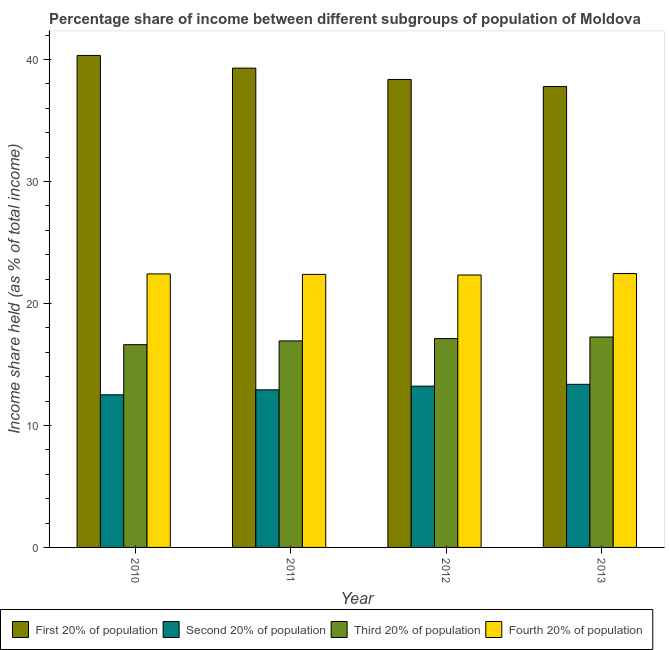Are the number of bars per tick equal to the number of legend labels?
Your answer should be compact. Yes. Are the number of bars on each tick of the X-axis equal?
Make the answer very short. Yes. What is the label of the 3rd group of bars from the left?
Keep it short and to the point. 2012. What is the share of the income held by second 20% of the population in 2013?
Ensure brevity in your answer.  13.37. Across all years, what is the maximum share of the income held by third 20% of the population?
Make the answer very short. 17.25. Across all years, what is the minimum share of the income held by first 20% of the population?
Give a very brief answer. 37.78. In which year was the share of the income held by first 20% of the population maximum?
Ensure brevity in your answer.  2010. In which year was the share of the income held by third 20% of the population minimum?
Your response must be concise. 2010. What is the total share of the income held by second 20% of the population in the graph?
Your answer should be compact. 52.02. What is the difference between the share of the income held by fourth 20% of the population in 2010 and that in 2013?
Provide a short and direct response. -0.03. What is the difference between the share of the income held by second 20% of the population in 2010 and the share of the income held by third 20% of the population in 2012?
Your answer should be very brief. -0.71. What is the average share of the income held by second 20% of the population per year?
Keep it short and to the point. 13. In the year 2012, what is the difference between the share of the income held by third 20% of the population and share of the income held by second 20% of the population?
Provide a succinct answer. 0. What is the ratio of the share of the income held by fourth 20% of the population in 2010 to that in 2011?
Your response must be concise. 1. Is the share of the income held by first 20% of the population in 2011 less than that in 2013?
Ensure brevity in your answer.  No. Is the difference between the share of the income held by second 20% of the population in 2010 and 2011 greater than the difference between the share of the income held by first 20% of the population in 2010 and 2011?
Your response must be concise. No. What is the difference between the highest and the second highest share of the income held by third 20% of the population?
Keep it short and to the point. 0.13. What is the difference between the highest and the lowest share of the income held by fourth 20% of the population?
Keep it short and to the point. 0.12. Is the sum of the share of the income held by second 20% of the population in 2010 and 2011 greater than the maximum share of the income held by first 20% of the population across all years?
Provide a succinct answer. Yes. Is it the case that in every year, the sum of the share of the income held by fourth 20% of the population and share of the income held by third 20% of the population is greater than the sum of share of the income held by second 20% of the population and share of the income held by first 20% of the population?
Ensure brevity in your answer.  Yes. What does the 3rd bar from the left in 2013 represents?
Offer a terse response. Third 20% of population. What does the 2nd bar from the right in 2013 represents?
Offer a very short reply. Third 20% of population. Is it the case that in every year, the sum of the share of the income held by first 20% of the population and share of the income held by second 20% of the population is greater than the share of the income held by third 20% of the population?
Offer a terse response. Yes. Are all the bars in the graph horizontal?
Your answer should be compact. No. How many years are there in the graph?
Give a very brief answer. 4. What is the difference between two consecutive major ticks on the Y-axis?
Your answer should be compact. 10. Are the values on the major ticks of Y-axis written in scientific E-notation?
Offer a very short reply. No. Does the graph contain any zero values?
Offer a terse response. No. Does the graph contain grids?
Your response must be concise. No. Where does the legend appear in the graph?
Your answer should be compact. Bottom left. How many legend labels are there?
Make the answer very short. 4. How are the legend labels stacked?
Make the answer very short. Horizontal. What is the title of the graph?
Your answer should be compact. Percentage share of income between different subgroups of population of Moldova. What is the label or title of the X-axis?
Offer a terse response. Year. What is the label or title of the Y-axis?
Make the answer very short. Income share held (as % of total income). What is the Income share held (as % of total income) of First 20% of population in 2010?
Keep it short and to the point. 40.33. What is the Income share held (as % of total income) of Second 20% of population in 2010?
Ensure brevity in your answer.  12.51. What is the Income share held (as % of total income) in Third 20% of population in 2010?
Give a very brief answer. 16.62. What is the Income share held (as % of total income) of Fourth 20% of population in 2010?
Make the answer very short. 22.42. What is the Income share held (as % of total income) in First 20% of population in 2011?
Offer a terse response. 39.29. What is the Income share held (as % of total income) of Second 20% of population in 2011?
Keep it short and to the point. 12.92. What is the Income share held (as % of total income) in Third 20% of population in 2011?
Offer a terse response. 16.93. What is the Income share held (as % of total income) of Fourth 20% of population in 2011?
Give a very brief answer. 22.38. What is the Income share held (as % of total income) of First 20% of population in 2012?
Your answer should be compact. 38.36. What is the Income share held (as % of total income) in Second 20% of population in 2012?
Offer a very short reply. 13.22. What is the Income share held (as % of total income) of Third 20% of population in 2012?
Your answer should be very brief. 17.12. What is the Income share held (as % of total income) in Fourth 20% of population in 2012?
Offer a very short reply. 22.33. What is the Income share held (as % of total income) of First 20% of population in 2013?
Give a very brief answer. 37.78. What is the Income share held (as % of total income) in Second 20% of population in 2013?
Make the answer very short. 13.37. What is the Income share held (as % of total income) of Third 20% of population in 2013?
Make the answer very short. 17.25. What is the Income share held (as % of total income) in Fourth 20% of population in 2013?
Keep it short and to the point. 22.45. Across all years, what is the maximum Income share held (as % of total income) in First 20% of population?
Offer a very short reply. 40.33. Across all years, what is the maximum Income share held (as % of total income) of Second 20% of population?
Give a very brief answer. 13.37. Across all years, what is the maximum Income share held (as % of total income) of Third 20% of population?
Offer a very short reply. 17.25. Across all years, what is the maximum Income share held (as % of total income) of Fourth 20% of population?
Your answer should be compact. 22.45. Across all years, what is the minimum Income share held (as % of total income) in First 20% of population?
Ensure brevity in your answer.  37.78. Across all years, what is the minimum Income share held (as % of total income) of Second 20% of population?
Your answer should be compact. 12.51. Across all years, what is the minimum Income share held (as % of total income) in Third 20% of population?
Provide a succinct answer. 16.62. Across all years, what is the minimum Income share held (as % of total income) of Fourth 20% of population?
Offer a terse response. 22.33. What is the total Income share held (as % of total income) in First 20% of population in the graph?
Make the answer very short. 155.76. What is the total Income share held (as % of total income) in Second 20% of population in the graph?
Provide a short and direct response. 52.02. What is the total Income share held (as % of total income) in Third 20% of population in the graph?
Your response must be concise. 67.92. What is the total Income share held (as % of total income) in Fourth 20% of population in the graph?
Provide a succinct answer. 89.58. What is the difference between the Income share held (as % of total income) in First 20% of population in 2010 and that in 2011?
Your response must be concise. 1.04. What is the difference between the Income share held (as % of total income) of Second 20% of population in 2010 and that in 2011?
Keep it short and to the point. -0.41. What is the difference between the Income share held (as % of total income) of Third 20% of population in 2010 and that in 2011?
Offer a terse response. -0.31. What is the difference between the Income share held (as % of total income) of Fourth 20% of population in 2010 and that in 2011?
Ensure brevity in your answer.  0.04. What is the difference between the Income share held (as % of total income) of First 20% of population in 2010 and that in 2012?
Make the answer very short. 1.97. What is the difference between the Income share held (as % of total income) in Second 20% of population in 2010 and that in 2012?
Give a very brief answer. -0.71. What is the difference between the Income share held (as % of total income) in Fourth 20% of population in 2010 and that in 2012?
Provide a short and direct response. 0.09. What is the difference between the Income share held (as % of total income) of First 20% of population in 2010 and that in 2013?
Your response must be concise. 2.55. What is the difference between the Income share held (as % of total income) of Second 20% of population in 2010 and that in 2013?
Ensure brevity in your answer.  -0.86. What is the difference between the Income share held (as % of total income) of Third 20% of population in 2010 and that in 2013?
Offer a terse response. -0.63. What is the difference between the Income share held (as % of total income) in Fourth 20% of population in 2010 and that in 2013?
Your response must be concise. -0.03. What is the difference between the Income share held (as % of total income) of Second 20% of population in 2011 and that in 2012?
Your answer should be very brief. -0.3. What is the difference between the Income share held (as % of total income) of Third 20% of population in 2011 and that in 2012?
Provide a succinct answer. -0.19. What is the difference between the Income share held (as % of total income) of First 20% of population in 2011 and that in 2013?
Your answer should be compact. 1.51. What is the difference between the Income share held (as % of total income) in Second 20% of population in 2011 and that in 2013?
Your response must be concise. -0.45. What is the difference between the Income share held (as % of total income) in Third 20% of population in 2011 and that in 2013?
Provide a succinct answer. -0.32. What is the difference between the Income share held (as % of total income) in Fourth 20% of population in 2011 and that in 2013?
Your answer should be compact. -0.07. What is the difference between the Income share held (as % of total income) of First 20% of population in 2012 and that in 2013?
Your response must be concise. 0.58. What is the difference between the Income share held (as % of total income) of Second 20% of population in 2012 and that in 2013?
Provide a short and direct response. -0.15. What is the difference between the Income share held (as % of total income) of Third 20% of population in 2012 and that in 2013?
Make the answer very short. -0.13. What is the difference between the Income share held (as % of total income) of Fourth 20% of population in 2012 and that in 2013?
Provide a short and direct response. -0.12. What is the difference between the Income share held (as % of total income) in First 20% of population in 2010 and the Income share held (as % of total income) in Second 20% of population in 2011?
Your answer should be very brief. 27.41. What is the difference between the Income share held (as % of total income) of First 20% of population in 2010 and the Income share held (as % of total income) of Third 20% of population in 2011?
Provide a succinct answer. 23.4. What is the difference between the Income share held (as % of total income) of First 20% of population in 2010 and the Income share held (as % of total income) of Fourth 20% of population in 2011?
Your answer should be very brief. 17.95. What is the difference between the Income share held (as % of total income) in Second 20% of population in 2010 and the Income share held (as % of total income) in Third 20% of population in 2011?
Provide a succinct answer. -4.42. What is the difference between the Income share held (as % of total income) in Second 20% of population in 2010 and the Income share held (as % of total income) in Fourth 20% of population in 2011?
Keep it short and to the point. -9.87. What is the difference between the Income share held (as % of total income) in Third 20% of population in 2010 and the Income share held (as % of total income) in Fourth 20% of population in 2011?
Provide a succinct answer. -5.76. What is the difference between the Income share held (as % of total income) in First 20% of population in 2010 and the Income share held (as % of total income) in Second 20% of population in 2012?
Your answer should be compact. 27.11. What is the difference between the Income share held (as % of total income) in First 20% of population in 2010 and the Income share held (as % of total income) in Third 20% of population in 2012?
Your response must be concise. 23.21. What is the difference between the Income share held (as % of total income) of Second 20% of population in 2010 and the Income share held (as % of total income) of Third 20% of population in 2012?
Your answer should be compact. -4.61. What is the difference between the Income share held (as % of total income) of Second 20% of population in 2010 and the Income share held (as % of total income) of Fourth 20% of population in 2012?
Your answer should be compact. -9.82. What is the difference between the Income share held (as % of total income) in Third 20% of population in 2010 and the Income share held (as % of total income) in Fourth 20% of population in 2012?
Provide a succinct answer. -5.71. What is the difference between the Income share held (as % of total income) in First 20% of population in 2010 and the Income share held (as % of total income) in Second 20% of population in 2013?
Your response must be concise. 26.96. What is the difference between the Income share held (as % of total income) in First 20% of population in 2010 and the Income share held (as % of total income) in Third 20% of population in 2013?
Keep it short and to the point. 23.08. What is the difference between the Income share held (as % of total income) in First 20% of population in 2010 and the Income share held (as % of total income) in Fourth 20% of population in 2013?
Offer a terse response. 17.88. What is the difference between the Income share held (as % of total income) of Second 20% of population in 2010 and the Income share held (as % of total income) of Third 20% of population in 2013?
Provide a short and direct response. -4.74. What is the difference between the Income share held (as % of total income) in Second 20% of population in 2010 and the Income share held (as % of total income) in Fourth 20% of population in 2013?
Offer a terse response. -9.94. What is the difference between the Income share held (as % of total income) of Third 20% of population in 2010 and the Income share held (as % of total income) of Fourth 20% of population in 2013?
Ensure brevity in your answer.  -5.83. What is the difference between the Income share held (as % of total income) of First 20% of population in 2011 and the Income share held (as % of total income) of Second 20% of population in 2012?
Ensure brevity in your answer.  26.07. What is the difference between the Income share held (as % of total income) in First 20% of population in 2011 and the Income share held (as % of total income) in Third 20% of population in 2012?
Offer a terse response. 22.17. What is the difference between the Income share held (as % of total income) of First 20% of population in 2011 and the Income share held (as % of total income) of Fourth 20% of population in 2012?
Offer a terse response. 16.96. What is the difference between the Income share held (as % of total income) of Second 20% of population in 2011 and the Income share held (as % of total income) of Fourth 20% of population in 2012?
Offer a very short reply. -9.41. What is the difference between the Income share held (as % of total income) of First 20% of population in 2011 and the Income share held (as % of total income) of Second 20% of population in 2013?
Provide a short and direct response. 25.92. What is the difference between the Income share held (as % of total income) of First 20% of population in 2011 and the Income share held (as % of total income) of Third 20% of population in 2013?
Give a very brief answer. 22.04. What is the difference between the Income share held (as % of total income) of First 20% of population in 2011 and the Income share held (as % of total income) of Fourth 20% of population in 2013?
Your response must be concise. 16.84. What is the difference between the Income share held (as % of total income) of Second 20% of population in 2011 and the Income share held (as % of total income) of Third 20% of population in 2013?
Provide a short and direct response. -4.33. What is the difference between the Income share held (as % of total income) in Second 20% of population in 2011 and the Income share held (as % of total income) in Fourth 20% of population in 2013?
Give a very brief answer. -9.53. What is the difference between the Income share held (as % of total income) of Third 20% of population in 2011 and the Income share held (as % of total income) of Fourth 20% of population in 2013?
Your answer should be compact. -5.52. What is the difference between the Income share held (as % of total income) in First 20% of population in 2012 and the Income share held (as % of total income) in Second 20% of population in 2013?
Provide a short and direct response. 24.99. What is the difference between the Income share held (as % of total income) of First 20% of population in 2012 and the Income share held (as % of total income) of Third 20% of population in 2013?
Your answer should be compact. 21.11. What is the difference between the Income share held (as % of total income) in First 20% of population in 2012 and the Income share held (as % of total income) in Fourth 20% of population in 2013?
Provide a short and direct response. 15.91. What is the difference between the Income share held (as % of total income) in Second 20% of population in 2012 and the Income share held (as % of total income) in Third 20% of population in 2013?
Ensure brevity in your answer.  -4.03. What is the difference between the Income share held (as % of total income) in Second 20% of population in 2012 and the Income share held (as % of total income) in Fourth 20% of population in 2013?
Provide a succinct answer. -9.23. What is the difference between the Income share held (as % of total income) of Third 20% of population in 2012 and the Income share held (as % of total income) of Fourth 20% of population in 2013?
Make the answer very short. -5.33. What is the average Income share held (as % of total income) in First 20% of population per year?
Offer a terse response. 38.94. What is the average Income share held (as % of total income) of Second 20% of population per year?
Offer a very short reply. 13.01. What is the average Income share held (as % of total income) in Third 20% of population per year?
Your answer should be very brief. 16.98. What is the average Income share held (as % of total income) of Fourth 20% of population per year?
Offer a terse response. 22.39. In the year 2010, what is the difference between the Income share held (as % of total income) of First 20% of population and Income share held (as % of total income) of Second 20% of population?
Make the answer very short. 27.82. In the year 2010, what is the difference between the Income share held (as % of total income) in First 20% of population and Income share held (as % of total income) in Third 20% of population?
Your answer should be very brief. 23.71. In the year 2010, what is the difference between the Income share held (as % of total income) in First 20% of population and Income share held (as % of total income) in Fourth 20% of population?
Provide a short and direct response. 17.91. In the year 2010, what is the difference between the Income share held (as % of total income) of Second 20% of population and Income share held (as % of total income) of Third 20% of population?
Your response must be concise. -4.11. In the year 2010, what is the difference between the Income share held (as % of total income) in Second 20% of population and Income share held (as % of total income) in Fourth 20% of population?
Offer a terse response. -9.91. In the year 2010, what is the difference between the Income share held (as % of total income) of Third 20% of population and Income share held (as % of total income) of Fourth 20% of population?
Your answer should be compact. -5.8. In the year 2011, what is the difference between the Income share held (as % of total income) of First 20% of population and Income share held (as % of total income) of Second 20% of population?
Ensure brevity in your answer.  26.37. In the year 2011, what is the difference between the Income share held (as % of total income) in First 20% of population and Income share held (as % of total income) in Third 20% of population?
Provide a short and direct response. 22.36. In the year 2011, what is the difference between the Income share held (as % of total income) of First 20% of population and Income share held (as % of total income) of Fourth 20% of population?
Make the answer very short. 16.91. In the year 2011, what is the difference between the Income share held (as % of total income) in Second 20% of population and Income share held (as % of total income) in Third 20% of population?
Provide a succinct answer. -4.01. In the year 2011, what is the difference between the Income share held (as % of total income) of Second 20% of population and Income share held (as % of total income) of Fourth 20% of population?
Provide a short and direct response. -9.46. In the year 2011, what is the difference between the Income share held (as % of total income) of Third 20% of population and Income share held (as % of total income) of Fourth 20% of population?
Your response must be concise. -5.45. In the year 2012, what is the difference between the Income share held (as % of total income) in First 20% of population and Income share held (as % of total income) in Second 20% of population?
Your answer should be compact. 25.14. In the year 2012, what is the difference between the Income share held (as % of total income) of First 20% of population and Income share held (as % of total income) of Third 20% of population?
Keep it short and to the point. 21.24. In the year 2012, what is the difference between the Income share held (as % of total income) of First 20% of population and Income share held (as % of total income) of Fourth 20% of population?
Ensure brevity in your answer.  16.03. In the year 2012, what is the difference between the Income share held (as % of total income) in Second 20% of population and Income share held (as % of total income) in Third 20% of population?
Give a very brief answer. -3.9. In the year 2012, what is the difference between the Income share held (as % of total income) of Second 20% of population and Income share held (as % of total income) of Fourth 20% of population?
Provide a succinct answer. -9.11. In the year 2012, what is the difference between the Income share held (as % of total income) in Third 20% of population and Income share held (as % of total income) in Fourth 20% of population?
Provide a succinct answer. -5.21. In the year 2013, what is the difference between the Income share held (as % of total income) in First 20% of population and Income share held (as % of total income) in Second 20% of population?
Keep it short and to the point. 24.41. In the year 2013, what is the difference between the Income share held (as % of total income) in First 20% of population and Income share held (as % of total income) in Third 20% of population?
Give a very brief answer. 20.53. In the year 2013, what is the difference between the Income share held (as % of total income) of First 20% of population and Income share held (as % of total income) of Fourth 20% of population?
Keep it short and to the point. 15.33. In the year 2013, what is the difference between the Income share held (as % of total income) in Second 20% of population and Income share held (as % of total income) in Third 20% of population?
Give a very brief answer. -3.88. In the year 2013, what is the difference between the Income share held (as % of total income) of Second 20% of population and Income share held (as % of total income) of Fourth 20% of population?
Offer a very short reply. -9.08. What is the ratio of the Income share held (as % of total income) of First 20% of population in 2010 to that in 2011?
Make the answer very short. 1.03. What is the ratio of the Income share held (as % of total income) of Second 20% of population in 2010 to that in 2011?
Your answer should be very brief. 0.97. What is the ratio of the Income share held (as % of total income) in Third 20% of population in 2010 to that in 2011?
Provide a short and direct response. 0.98. What is the ratio of the Income share held (as % of total income) of First 20% of population in 2010 to that in 2012?
Your answer should be compact. 1.05. What is the ratio of the Income share held (as % of total income) in Second 20% of population in 2010 to that in 2012?
Your answer should be compact. 0.95. What is the ratio of the Income share held (as % of total income) in Third 20% of population in 2010 to that in 2012?
Your answer should be very brief. 0.97. What is the ratio of the Income share held (as % of total income) in First 20% of population in 2010 to that in 2013?
Ensure brevity in your answer.  1.07. What is the ratio of the Income share held (as % of total income) in Second 20% of population in 2010 to that in 2013?
Offer a very short reply. 0.94. What is the ratio of the Income share held (as % of total income) of Third 20% of population in 2010 to that in 2013?
Give a very brief answer. 0.96. What is the ratio of the Income share held (as % of total income) of First 20% of population in 2011 to that in 2012?
Offer a terse response. 1.02. What is the ratio of the Income share held (as % of total income) of Second 20% of population in 2011 to that in 2012?
Offer a very short reply. 0.98. What is the ratio of the Income share held (as % of total income) in Third 20% of population in 2011 to that in 2012?
Offer a very short reply. 0.99. What is the ratio of the Income share held (as % of total income) of First 20% of population in 2011 to that in 2013?
Your answer should be very brief. 1.04. What is the ratio of the Income share held (as % of total income) of Second 20% of population in 2011 to that in 2013?
Offer a very short reply. 0.97. What is the ratio of the Income share held (as % of total income) in Third 20% of population in 2011 to that in 2013?
Provide a short and direct response. 0.98. What is the ratio of the Income share held (as % of total income) in First 20% of population in 2012 to that in 2013?
Your response must be concise. 1.02. What is the ratio of the Income share held (as % of total income) of Second 20% of population in 2012 to that in 2013?
Your response must be concise. 0.99. What is the ratio of the Income share held (as % of total income) of Third 20% of population in 2012 to that in 2013?
Provide a short and direct response. 0.99. What is the difference between the highest and the second highest Income share held (as % of total income) of Third 20% of population?
Your answer should be compact. 0.13. What is the difference between the highest and the second highest Income share held (as % of total income) in Fourth 20% of population?
Your answer should be very brief. 0.03. What is the difference between the highest and the lowest Income share held (as % of total income) in First 20% of population?
Your answer should be compact. 2.55. What is the difference between the highest and the lowest Income share held (as % of total income) of Second 20% of population?
Offer a terse response. 0.86. What is the difference between the highest and the lowest Income share held (as % of total income) in Third 20% of population?
Your response must be concise. 0.63. What is the difference between the highest and the lowest Income share held (as % of total income) of Fourth 20% of population?
Offer a very short reply. 0.12. 